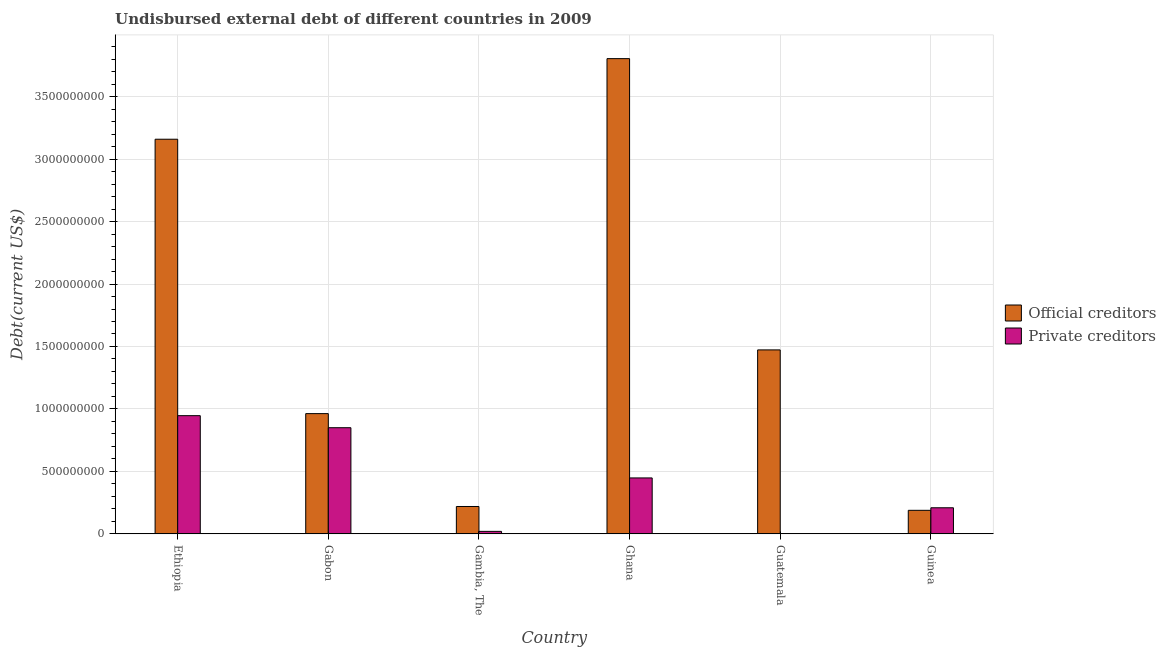How many different coloured bars are there?
Ensure brevity in your answer.  2. Are the number of bars on each tick of the X-axis equal?
Ensure brevity in your answer.  Yes. What is the label of the 4th group of bars from the left?
Your answer should be very brief. Ghana. What is the undisbursed external debt of private creditors in Ethiopia?
Offer a very short reply. 9.46e+08. Across all countries, what is the maximum undisbursed external debt of official creditors?
Provide a short and direct response. 3.80e+09. Across all countries, what is the minimum undisbursed external debt of official creditors?
Make the answer very short. 1.88e+08. In which country was the undisbursed external debt of private creditors minimum?
Keep it short and to the point. Guatemala. What is the total undisbursed external debt of private creditors in the graph?
Offer a very short reply. 2.47e+09. What is the difference between the undisbursed external debt of official creditors in Gabon and that in Ghana?
Provide a succinct answer. -2.84e+09. What is the difference between the undisbursed external debt of official creditors in Ghana and the undisbursed external debt of private creditors in Gabon?
Your response must be concise. 2.95e+09. What is the average undisbursed external debt of private creditors per country?
Your answer should be compact. 4.12e+08. What is the difference between the undisbursed external debt of private creditors and undisbursed external debt of official creditors in Gambia, The?
Keep it short and to the point. -1.99e+08. What is the ratio of the undisbursed external debt of private creditors in Ethiopia to that in Gabon?
Your response must be concise. 1.11. Is the undisbursed external debt of private creditors in Ethiopia less than that in Gambia, The?
Your answer should be very brief. No. What is the difference between the highest and the second highest undisbursed external debt of official creditors?
Offer a very short reply. 6.45e+08. What is the difference between the highest and the lowest undisbursed external debt of official creditors?
Ensure brevity in your answer.  3.62e+09. What does the 2nd bar from the left in Gambia, The represents?
Keep it short and to the point. Private creditors. What does the 2nd bar from the right in Gabon represents?
Keep it short and to the point. Official creditors. Are all the bars in the graph horizontal?
Provide a succinct answer. No. What is the difference between two consecutive major ticks on the Y-axis?
Make the answer very short. 5.00e+08. Are the values on the major ticks of Y-axis written in scientific E-notation?
Provide a short and direct response. No. Does the graph contain any zero values?
Offer a very short reply. No. Where does the legend appear in the graph?
Provide a short and direct response. Center right. What is the title of the graph?
Provide a succinct answer. Undisbursed external debt of different countries in 2009. Does "Ages 15-24" appear as one of the legend labels in the graph?
Provide a succinct answer. No. What is the label or title of the Y-axis?
Offer a terse response. Debt(current US$). What is the Debt(current US$) in Official creditors in Ethiopia?
Your answer should be compact. 3.16e+09. What is the Debt(current US$) of Private creditors in Ethiopia?
Your answer should be very brief. 9.46e+08. What is the Debt(current US$) in Official creditors in Gabon?
Your response must be concise. 9.63e+08. What is the Debt(current US$) in Private creditors in Gabon?
Your response must be concise. 8.50e+08. What is the Debt(current US$) of Official creditors in Gambia, The?
Provide a short and direct response. 2.19e+08. What is the Debt(current US$) in Private creditors in Gambia, The?
Give a very brief answer. 2.00e+07. What is the Debt(current US$) of Official creditors in Ghana?
Make the answer very short. 3.80e+09. What is the Debt(current US$) in Private creditors in Ghana?
Ensure brevity in your answer.  4.48e+08. What is the Debt(current US$) in Official creditors in Guatemala?
Provide a short and direct response. 1.47e+09. What is the Debt(current US$) in Private creditors in Guatemala?
Make the answer very short. 1.75e+06. What is the Debt(current US$) in Official creditors in Guinea?
Your answer should be compact. 1.88e+08. What is the Debt(current US$) in Private creditors in Guinea?
Your answer should be compact. 2.09e+08. Across all countries, what is the maximum Debt(current US$) of Official creditors?
Your response must be concise. 3.80e+09. Across all countries, what is the maximum Debt(current US$) of Private creditors?
Offer a very short reply. 9.46e+08. Across all countries, what is the minimum Debt(current US$) of Official creditors?
Keep it short and to the point. 1.88e+08. Across all countries, what is the minimum Debt(current US$) in Private creditors?
Your response must be concise. 1.75e+06. What is the total Debt(current US$) of Official creditors in the graph?
Make the answer very short. 9.81e+09. What is the total Debt(current US$) of Private creditors in the graph?
Provide a short and direct response. 2.47e+09. What is the difference between the Debt(current US$) in Official creditors in Ethiopia and that in Gabon?
Provide a succinct answer. 2.20e+09. What is the difference between the Debt(current US$) in Private creditors in Ethiopia and that in Gabon?
Keep it short and to the point. 9.65e+07. What is the difference between the Debt(current US$) of Official creditors in Ethiopia and that in Gambia, The?
Your response must be concise. 2.94e+09. What is the difference between the Debt(current US$) of Private creditors in Ethiopia and that in Gambia, The?
Provide a succinct answer. 9.26e+08. What is the difference between the Debt(current US$) in Official creditors in Ethiopia and that in Ghana?
Ensure brevity in your answer.  -6.45e+08. What is the difference between the Debt(current US$) of Private creditors in Ethiopia and that in Ghana?
Give a very brief answer. 4.99e+08. What is the difference between the Debt(current US$) in Official creditors in Ethiopia and that in Guatemala?
Provide a succinct answer. 1.69e+09. What is the difference between the Debt(current US$) of Private creditors in Ethiopia and that in Guatemala?
Provide a short and direct response. 9.44e+08. What is the difference between the Debt(current US$) of Official creditors in Ethiopia and that in Guinea?
Give a very brief answer. 2.97e+09. What is the difference between the Debt(current US$) in Private creditors in Ethiopia and that in Guinea?
Your answer should be compact. 7.37e+08. What is the difference between the Debt(current US$) of Official creditors in Gabon and that in Gambia, The?
Give a very brief answer. 7.43e+08. What is the difference between the Debt(current US$) of Private creditors in Gabon and that in Gambia, The?
Keep it short and to the point. 8.30e+08. What is the difference between the Debt(current US$) in Official creditors in Gabon and that in Ghana?
Provide a succinct answer. -2.84e+09. What is the difference between the Debt(current US$) of Private creditors in Gabon and that in Ghana?
Offer a very short reply. 4.02e+08. What is the difference between the Debt(current US$) in Official creditors in Gabon and that in Guatemala?
Offer a terse response. -5.10e+08. What is the difference between the Debt(current US$) in Private creditors in Gabon and that in Guatemala?
Provide a short and direct response. 8.48e+08. What is the difference between the Debt(current US$) in Official creditors in Gabon and that in Guinea?
Your answer should be very brief. 7.74e+08. What is the difference between the Debt(current US$) in Private creditors in Gabon and that in Guinea?
Ensure brevity in your answer.  6.41e+08. What is the difference between the Debt(current US$) in Official creditors in Gambia, The and that in Ghana?
Your response must be concise. -3.59e+09. What is the difference between the Debt(current US$) of Private creditors in Gambia, The and that in Ghana?
Ensure brevity in your answer.  -4.28e+08. What is the difference between the Debt(current US$) of Official creditors in Gambia, The and that in Guatemala?
Provide a succinct answer. -1.25e+09. What is the difference between the Debt(current US$) in Private creditors in Gambia, The and that in Guatemala?
Provide a succinct answer. 1.82e+07. What is the difference between the Debt(current US$) in Official creditors in Gambia, The and that in Guinea?
Provide a succinct answer. 3.07e+07. What is the difference between the Debt(current US$) of Private creditors in Gambia, The and that in Guinea?
Ensure brevity in your answer.  -1.89e+08. What is the difference between the Debt(current US$) in Official creditors in Ghana and that in Guatemala?
Offer a terse response. 2.33e+09. What is the difference between the Debt(current US$) of Private creditors in Ghana and that in Guatemala?
Your answer should be very brief. 4.46e+08. What is the difference between the Debt(current US$) of Official creditors in Ghana and that in Guinea?
Offer a very short reply. 3.62e+09. What is the difference between the Debt(current US$) of Private creditors in Ghana and that in Guinea?
Keep it short and to the point. 2.39e+08. What is the difference between the Debt(current US$) of Official creditors in Guatemala and that in Guinea?
Give a very brief answer. 1.28e+09. What is the difference between the Debt(current US$) in Private creditors in Guatemala and that in Guinea?
Your answer should be very brief. -2.07e+08. What is the difference between the Debt(current US$) in Official creditors in Ethiopia and the Debt(current US$) in Private creditors in Gabon?
Ensure brevity in your answer.  2.31e+09. What is the difference between the Debt(current US$) in Official creditors in Ethiopia and the Debt(current US$) in Private creditors in Gambia, The?
Provide a succinct answer. 3.14e+09. What is the difference between the Debt(current US$) in Official creditors in Ethiopia and the Debt(current US$) in Private creditors in Ghana?
Offer a very short reply. 2.71e+09. What is the difference between the Debt(current US$) of Official creditors in Ethiopia and the Debt(current US$) of Private creditors in Guatemala?
Offer a very short reply. 3.16e+09. What is the difference between the Debt(current US$) of Official creditors in Ethiopia and the Debt(current US$) of Private creditors in Guinea?
Keep it short and to the point. 2.95e+09. What is the difference between the Debt(current US$) in Official creditors in Gabon and the Debt(current US$) in Private creditors in Gambia, The?
Offer a very short reply. 9.43e+08. What is the difference between the Debt(current US$) of Official creditors in Gabon and the Debt(current US$) of Private creditors in Ghana?
Provide a short and direct response. 5.15e+08. What is the difference between the Debt(current US$) in Official creditors in Gabon and the Debt(current US$) in Private creditors in Guatemala?
Give a very brief answer. 9.61e+08. What is the difference between the Debt(current US$) of Official creditors in Gabon and the Debt(current US$) of Private creditors in Guinea?
Provide a succinct answer. 7.54e+08. What is the difference between the Debt(current US$) of Official creditors in Gambia, The and the Debt(current US$) of Private creditors in Ghana?
Ensure brevity in your answer.  -2.29e+08. What is the difference between the Debt(current US$) in Official creditors in Gambia, The and the Debt(current US$) in Private creditors in Guatemala?
Offer a terse response. 2.17e+08. What is the difference between the Debt(current US$) of Official creditors in Gambia, The and the Debt(current US$) of Private creditors in Guinea?
Keep it short and to the point. 1.03e+07. What is the difference between the Debt(current US$) in Official creditors in Ghana and the Debt(current US$) in Private creditors in Guatemala?
Your answer should be compact. 3.80e+09. What is the difference between the Debt(current US$) of Official creditors in Ghana and the Debt(current US$) of Private creditors in Guinea?
Your answer should be very brief. 3.60e+09. What is the difference between the Debt(current US$) in Official creditors in Guatemala and the Debt(current US$) in Private creditors in Guinea?
Provide a succinct answer. 1.26e+09. What is the average Debt(current US$) of Official creditors per country?
Keep it short and to the point. 1.63e+09. What is the average Debt(current US$) of Private creditors per country?
Provide a succinct answer. 4.12e+08. What is the difference between the Debt(current US$) in Official creditors and Debt(current US$) in Private creditors in Ethiopia?
Your answer should be compact. 2.21e+09. What is the difference between the Debt(current US$) in Official creditors and Debt(current US$) in Private creditors in Gabon?
Ensure brevity in your answer.  1.13e+08. What is the difference between the Debt(current US$) in Official creditors and Debt(current US$) in Private creditors in Gambia, The?
Offer a very short reply. 1.99e+08. What is the difference between the Debt(current US$) of Official creditors and Debt(current US$) of Private creditors in Ghana?
Make the answer very short. 3.36e+09. What is the difference between the Debt(current US$) in Official creditors and Debt(current US$) in Private creditors in Guatemala?
Offer a terse response. 1.47e+09. What is the difference between the Debt(current US$) of Official creditors and Debt(current US$) of Private creditors in Guinea?
Keep it short and to the point. -2.05e+07. What is the ratio of the Debt(current US$) of Official creditors in Ethiopia to that in Gabon?
Provide a succinct answer. 3.28. What is the ratio of the Debt(current US$) in Private creditors in Ethiopia to that in Gabon?
Provide a succinct answer. 1.11. What is the ratio of the Debt(current US$) in Official creditors in Ethiopia to that in Gambia, The?
Give a very brief answer. 14.42. What is the ratio of the Debt(current US$) in Private creditors in Ethiopia to that in Gambia, The?
Your answer should be compact. 47.34. What is the ratio of the Debt(current US$) in Official creditors in Ethiopia to that in Ghana?
Your answer should be very brief. 0.83. What is the ratio of the Debt(current US$) of Private creditors in Ethiopia to that in Ghana?
Provide a succinct answer. 2.11. What is the ratio of the Debt(current US$) in Official creditors in Ethiopia to that in Guatemala?
Your answer should be compact. 2.15. What is the ratio of the Debt(current US$) in Private creditors in Ethiopia to that in Guatemala?
Offer a terse response. 539.47. What is the ratio of the Debt(current US$) in Official creditors in Ethiopia to that in Guinea?
Your answer should be very brief. 16.77. What is the ratio of the Debt(current US$) in Private creditors in Ethiopia to that in Guinea?
Ensure brevity in your answer.  4.53. What is the ratio of the Debt(current US$) in Official creditors in Gabon to that in Gambia, The?
Give a very brief answer. 4.39. What is the ratio of the Debt(current US$) in Private creditors in Gabon to that in Gambia, The?
Provide a short and direct response. 42.51. What is the ratio of the Debt(current US$) of Official creditors in Gabon to that in Ghana?
Your response must be concise. 0.25. What is the ratio of the Debt(current US$) in Private creditors in Gabon to that in Ghana?
Provide a succinct answer. 1.9. What is the ratio of the Debt(current US$) of Official creditors in Gabon to that in Guatemala?
Provide a succinct answer. 0.65. What is the ratio of the Debt(current US$) in Private creditors in Gabon to that in Guatemala?
Offer a terse response. 484.47. What is the ratio of the Debt(current US$) in Official creditors in Gabon to that in Guinea?
Offer a terse response. 5.11. What is the ratio of the Debt(current US$) of Private creditors in Gabon to that in Guinea?
Offer a terse response. 4.07. What is the ratio of the Debt(current US$) of Official creditors in Gambia, The to that in Ghana?
Make the answer very short. 0.06. What is the ratio of the Debt(current US$) in Private creditors in Gambia, The to that in Ghana?
Your answer should be compact. 0.04. What is the ratio of the Debt(current US$) of Official creditors in Gambia, The to that in Guatemala?
Your answer should be very brief. 0.15. What is the ratio of the Debt(current US$) in Private creditors in Gambia, The to that in Guatemala?
Provide a succinct answer. 11.4. What is the ratio of the Debt(current US$) of Official creditors in Gambia, The to that in Guinea?
Your answer should be very brief. 1.16. What is the ratio of the Debt(current US$) of Private creditors in Gambia, The to that in Guinea?
Keep it short and to the point. 0.1. What is the ratio of the Debt(current US$) in Official creditors in Ghana to that in Guatemala?
Offer a very short reply. 2.58. What is the ratio of the Debt(current US$) of Private creditors in Ghana to that in Guatemala?
Provide a short and direct response. 255.25. What is the ratio of the Debt(current US$) of Official creditors in Ghana to that in Guinea?
Make the answer very short. 20.19. What is the ratio of the Debt(current US$) in Private creditors in Ghana to that in Guinea?
Keep it short and to the point. 2.14. What is the ratio of the Debt(current US$) in Official creditors in Guatemala to that in Guinea?
Your answer should be very brief. 7.82. What is the ratio of the Debt(current US$) of Private creditors in Guatemala to that in Guinea?
Ensure brevity in your answer.  0.01. What is the difference between the highest and the second highest Debt(current US$) of Official creditors?
Your answer should be very brief. 6.45e+08. What is the difference between the highest and the second highest Debt(current US$) of Private creditors?
Make the answer very short. 9.65e+07. What is the difference between the highest and the lowest Debt(current US$) of Official creditors?
Ensure brevity in your answer.  3.62e+09. What is the difference between the highest and the lowest Debt(current US$) in Private creditors?
Your answer should be very brief. 9.44e+08. 